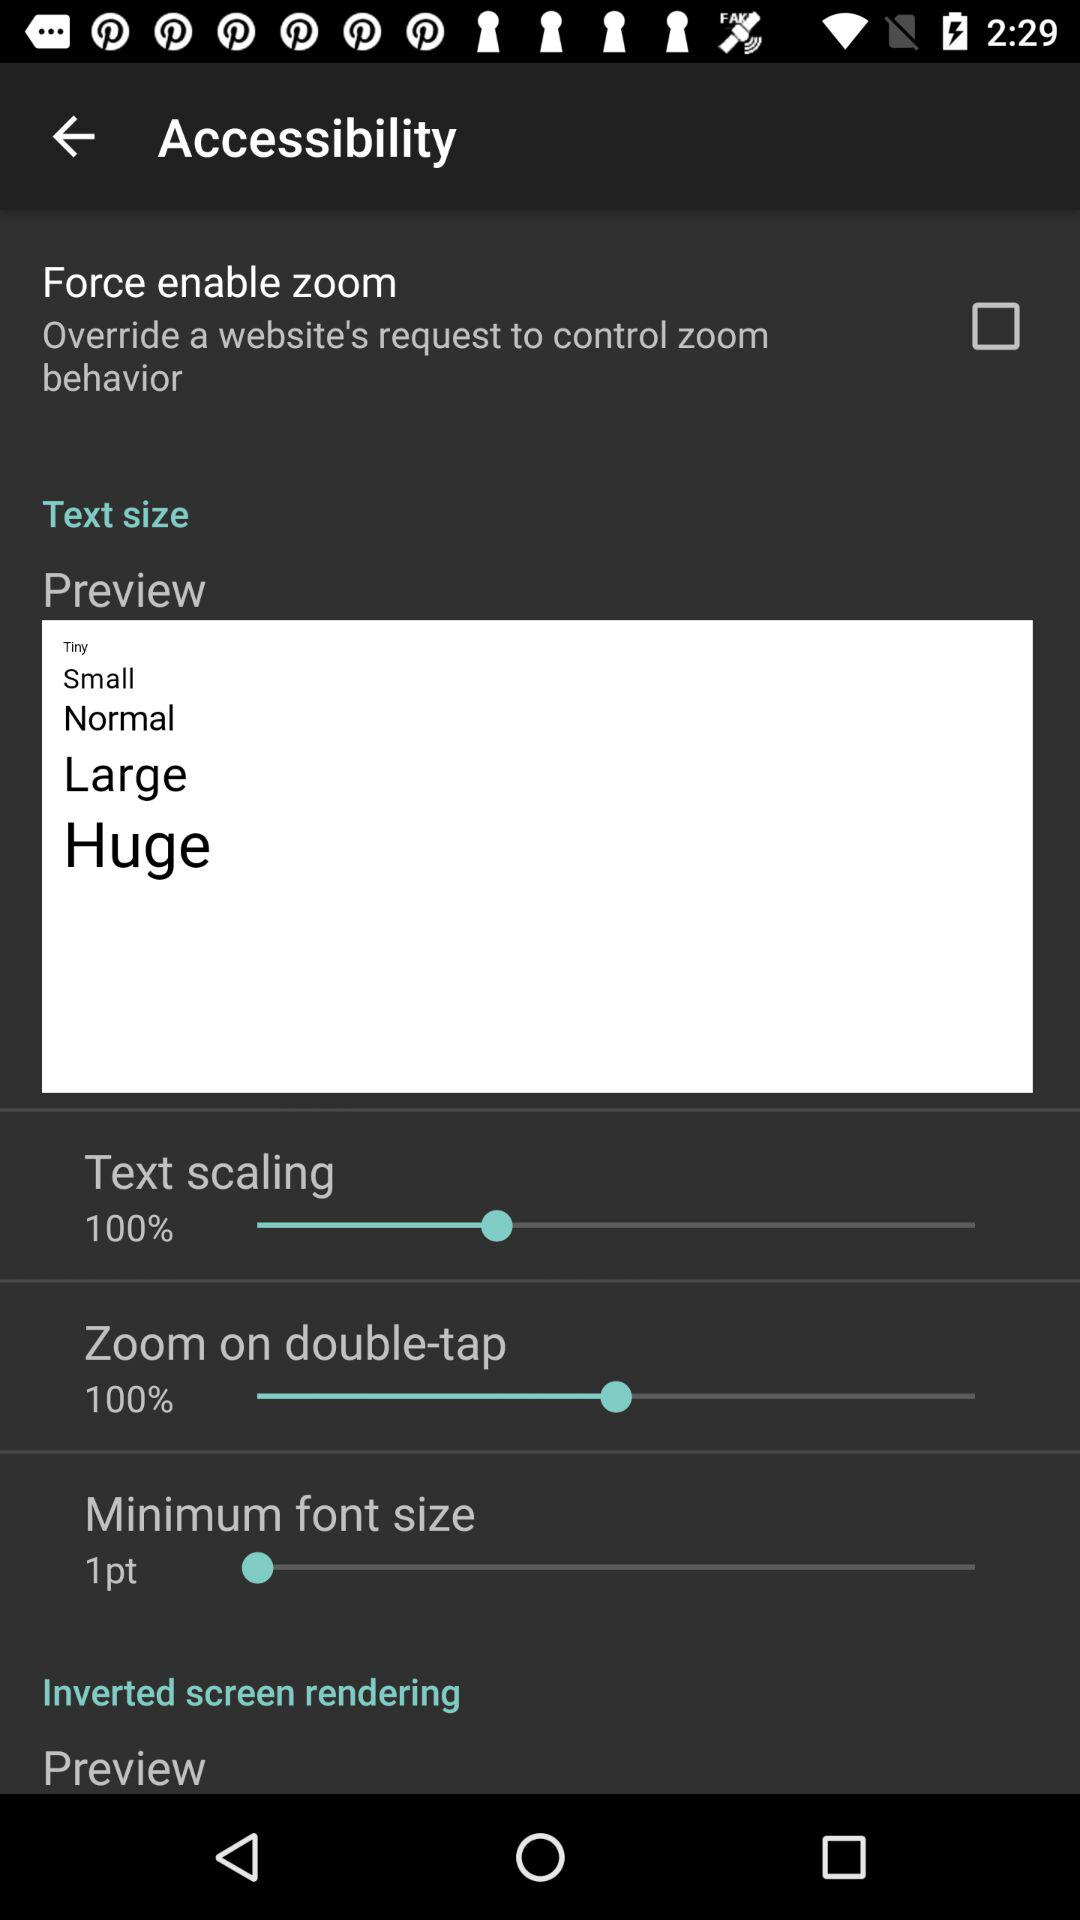What option should we select to "Override a website's request to control zoom behavior"? You should select "Force enable zoom" option. 